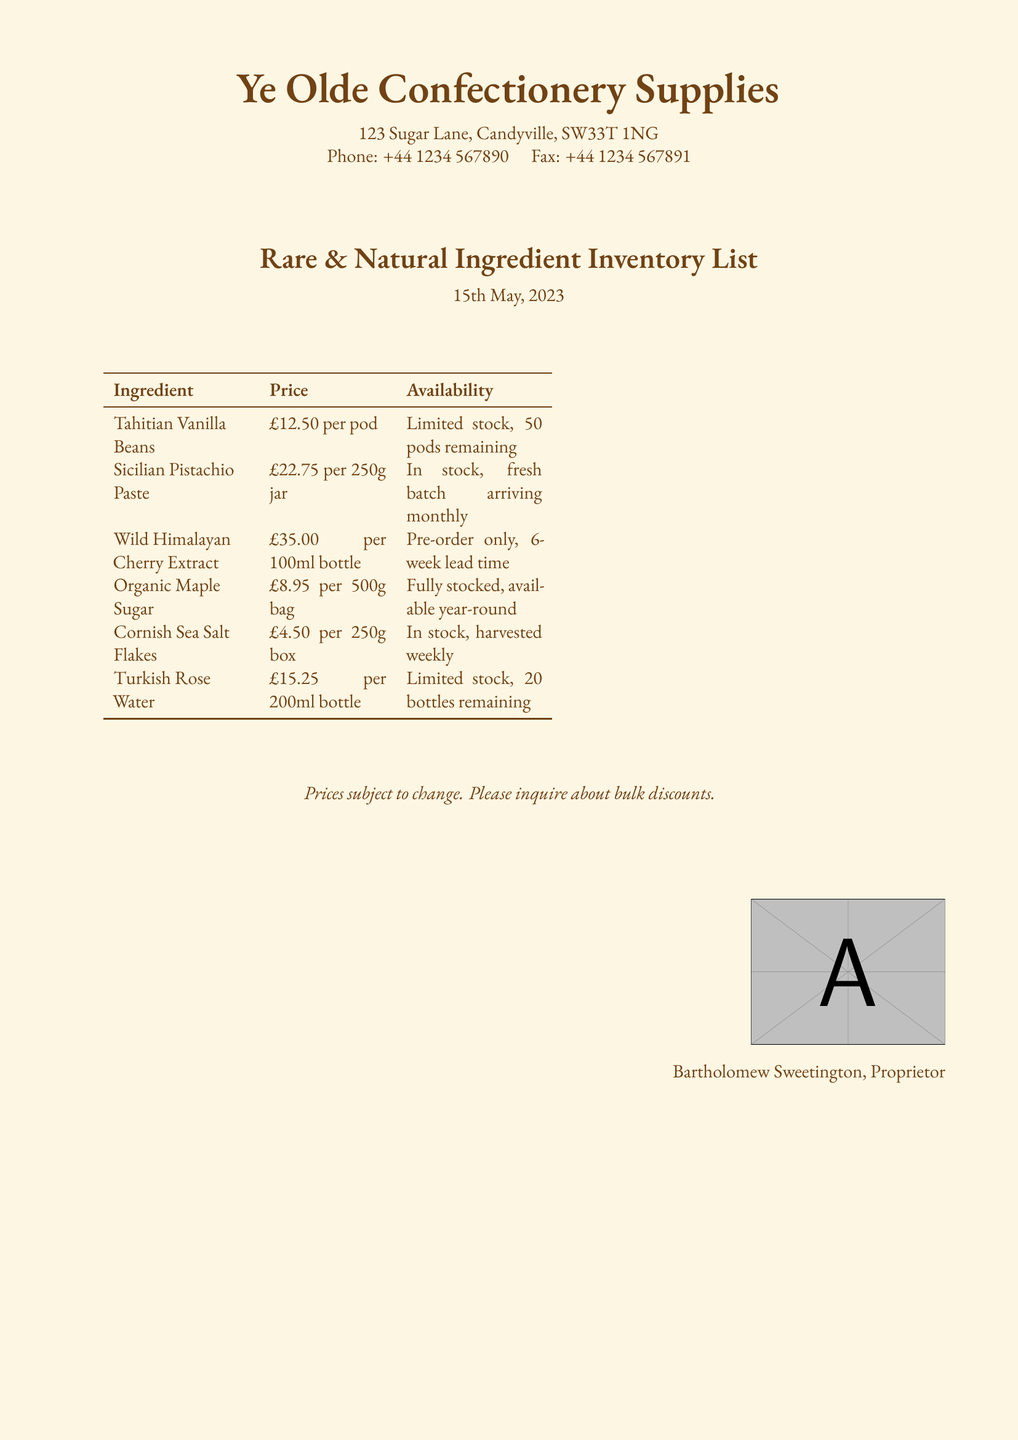What is the date of the inventory list? The date of the inventory list is stated at the top of the document as 15th May, 2023.
Answer: 15th May, 2023 How much do Tahitian Vanilla Beans cost? The cost of Tahitian Vanilla Beans is specified in the document as £12.50 per pod.
Answer: £12.50 per pod What is the availability status of the Wild Himalayan Cherry Extract? The document indicates that Wild Himalayan Cherry Extract is available for pre-order only with a lead time of 6 weeks.
Answer: Pre-order only, 6-week lead time How many Sicilian Pistachio Paste jars are available? The document states that Sicilian Pistachio Paste is in stock and a fresh batch arrives monthly, implying a continuous supply without specific limits.
Answer: In stock What is the price for Cornish Sea Salt Flakes? The document lists the price for Cornish Sea Salt Flakes as £4.50 per 250g box.
Answer: £4.50 per 250g box How many Tahitian Vanilla Beans are left in stock? The document specifies that there are 50 pods remaining for Tahitian Vanilla Beans.
Answer: 50 pods remaining What ingredient has a limited stock of 20 bottles? According to the document, Turkish Rose Water has a limited stock of 20 bottles remaining.
Answer: Turkish Rose Water Is there any mention of bulk discounts? The document includes a note about prices being subject to change and encourages inquiries about bulk discounts.
Answer: Yes 